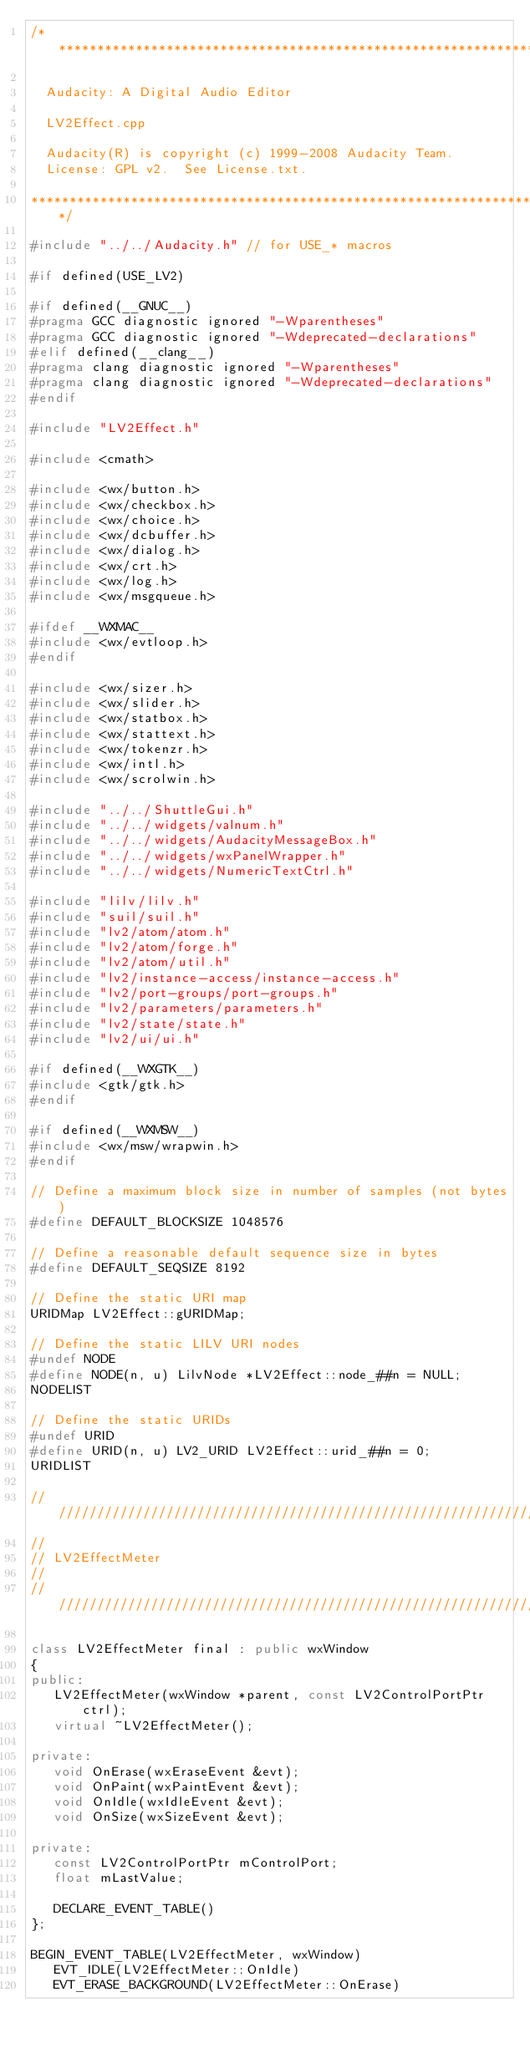Convert code to text. <code><loc_0><loc_0><loc_500><loc_500><_C++_>/**********************************************************************

  Audacity: A Digital Audio Editor

  LV2Effect.cpp

  Audacity(R) is copyright (c) 1999-2008 Audacity Team.
  License: GPL v2.  See License.txt.

**********************************************************************/

#include "../../Audacity.h" // for USE_* macros

#if defined(USE_LV2)

#if defined(__GNUC__)
#pragma GCC diagnostic ignored "-Wparentheses"
#pragma GCC diagnostic ignored "-Wdeprecated-declarations"
#elif defined(__clang__)
#pragma clang diagnostic ignored "-Wparentheses"
#pragma clang diagnostic ignored "-Wdeprecated-declarations"
#endif

#include "LV2Effect.h"

#include <cmath>

#include <wx/button.h>
#include <wx/checkbox.h>
#include <wx/choice.h>
#include <wx/dcbuffer.h>
#include <wx/dialog.h>
#include <wx/crt.h>
#include <wx/log.h>
#include <wx/msgqueue.h>

#ifdef __WXMAC__
#include <wx/evtloop.h>
#endif

#include <wx/sizer.h>
#include <wx/slider.h>
#include <wx/statbox.h>
#include <wx/stattext.h>
#include <wx/tokenzr.h>
#include <wx/intl.h>
#include <wx/scrolwin.h>

#include "../../ShuttleGui.h"
#include "../../widgets/valnum.h"
#include "../../widgets/AudacityMessageBox.h"
#include "../../widgets/wxPanelWrapper.h"
#include "../../widgets/NumericTextCtrl.h"

#include "lilv/lilv.h"
#include "suil/suil.h"
#include "lv2/atom/atom.h"
#include "lv2/atom/forge.h"
#include "lv2/atom/util.h"
#include "lv2/instance-access/instance-access.h"
#include "lv2/port-groups/port-groups.h"
#include "lv2/parameters/parameters.h"
#include "lv2/state/state.h"
#include "lv2/ui/ui.h"

#if defined(__WXGTK__)
#include <gtk/gtk.h>
#endif

#if defined(__WXMSW__)
#include <wx/msw/wrapwin.h>
#endif

// Define a maximum block size in number of samples (not bytes)
#define DEFAULT_BLOCKSIZE 1048576

// Define a reasonable default sequence size in bytes
#define DEFAULT_SEQSIZE 8192

// Define the static URI map
URIDMap LV2Effect::gURIDMap;

// Define the static LILV URI nodes
#undef NODE
#define NODE(n, u) LilvNode *LV2Effect::node_##n = NULL;
NODELIST

// Define the static URIDs
#undef URID
#define URID(n, u) LV2_URID LV2Effect::urid_##n = 0;
URIDLIST

///////////////////////////////////////////////////////////////////////////////
//
// LV2EffectMeter
//
///////////////////////////////////////////////////////////////////////////////

class LV2EffectMeter final : public wxWindow
{
public:
   LV2EffectMeter(wxWindow *parent, const LV2ControlPortPtr ctrl);
   virtual ~LV2EffectMeter();

private:
   void OnErase(wxEraseEvent &evt);
   void OnPaint(wxPaintEvent &evt);
   void OnIdle(wxIdleEvent &evt);
   void OnSize(wxSizeEvent &evt);

private:
   const LV2ControlPortPtr mControlPort;
   float mLastValue;

   DECLARE_EVENT_TABLE()
};

BEGIN_EVENT_TABLE(LV2EffectMeter, wxWindow)
   EVT_IDLE(LV2EffectMeter::OnIdle)
   EVT_ERASE_BACKGROUND(LV2EffectMeter::OnErase)</code> 